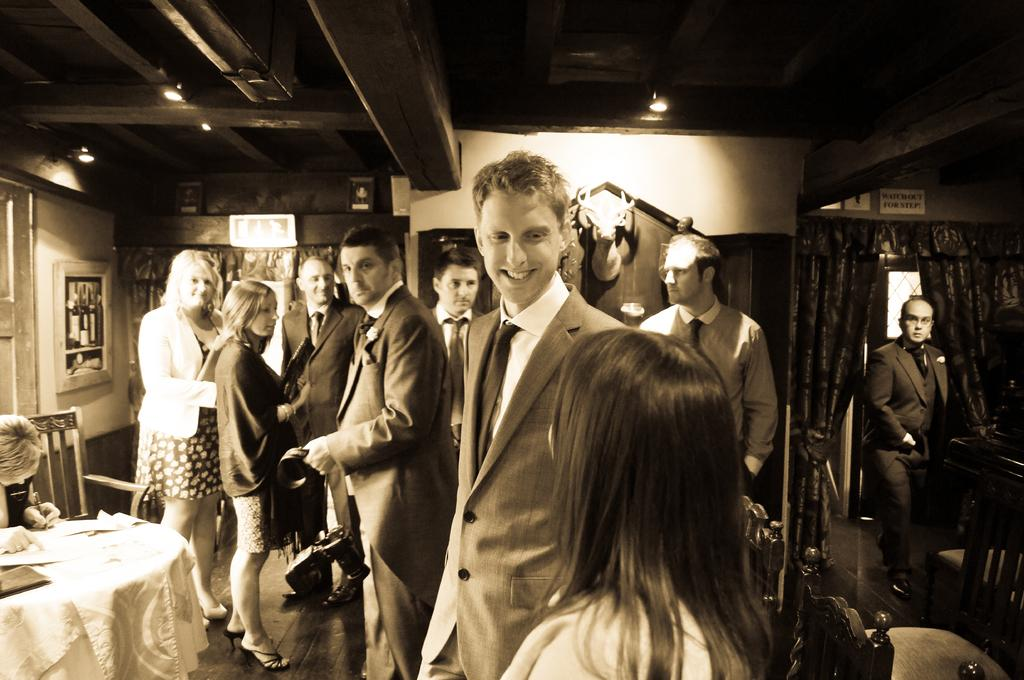How many people are in the image? There is a group of people in the image, but the exact number cannot be determined from the provided facts. What is the position of the people in the image? The people are on the ground in the image. What furniture is present in the image? There is a table and chairs in the image. What type of lighting is visible in the image? There are lights in the image. What architectural feature is present in the image? There is a wall in the image. What type of window treatment is present in the image? There are curtains in the image. What other objects can be seen in the image? There are some objects in the image, but their specific nature cannot be determined from the provided facts. What type of deer can be seen in the image? There is no deer present in the image. What nation is represented by the people in the image? The facts do not provide any information about the nationality or origin of the people in the image. 